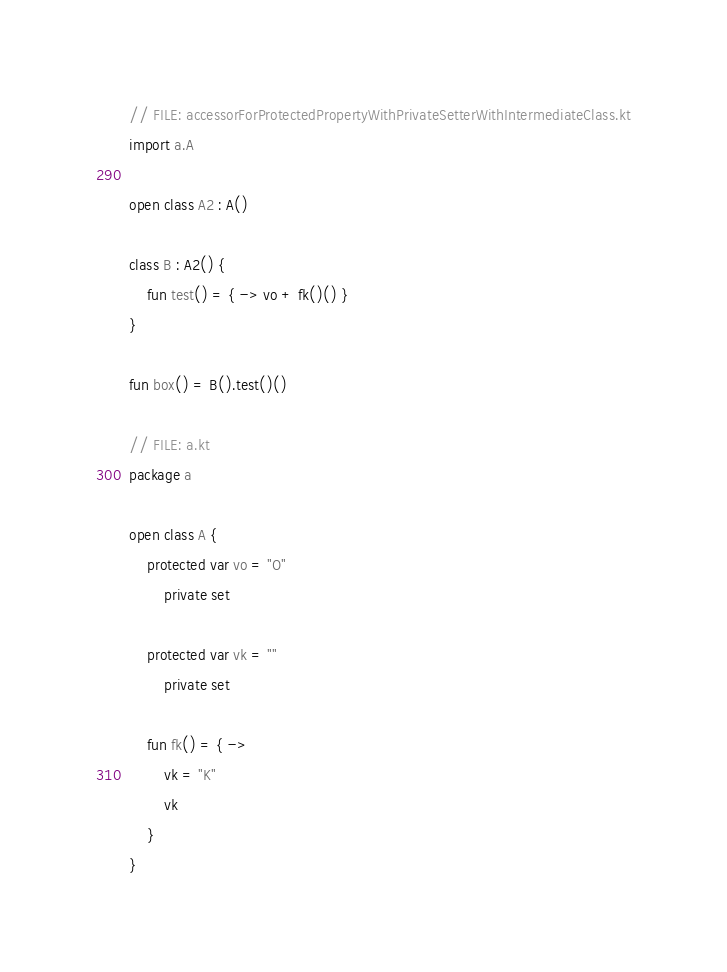Convert code to text. <code><loc_0><loc_0><loc_500><loc_500><_Kotlin_>// FILE: accessorForProtectedPropertyWithPrivateSetterWithIntermediateClass.kt
import a.A

open class A2 : A()

class B : A2() {
    fun test() = { -> vo + fk()() }
}

fun box() = B().test()()

// FILE: a.kt
package a

open class A {
    protected var vo = "O"
        private set

    protected var vk = ""
        private set

    fun fk() = { ->
        vk = "K"
        vk
    }
}
</code> 